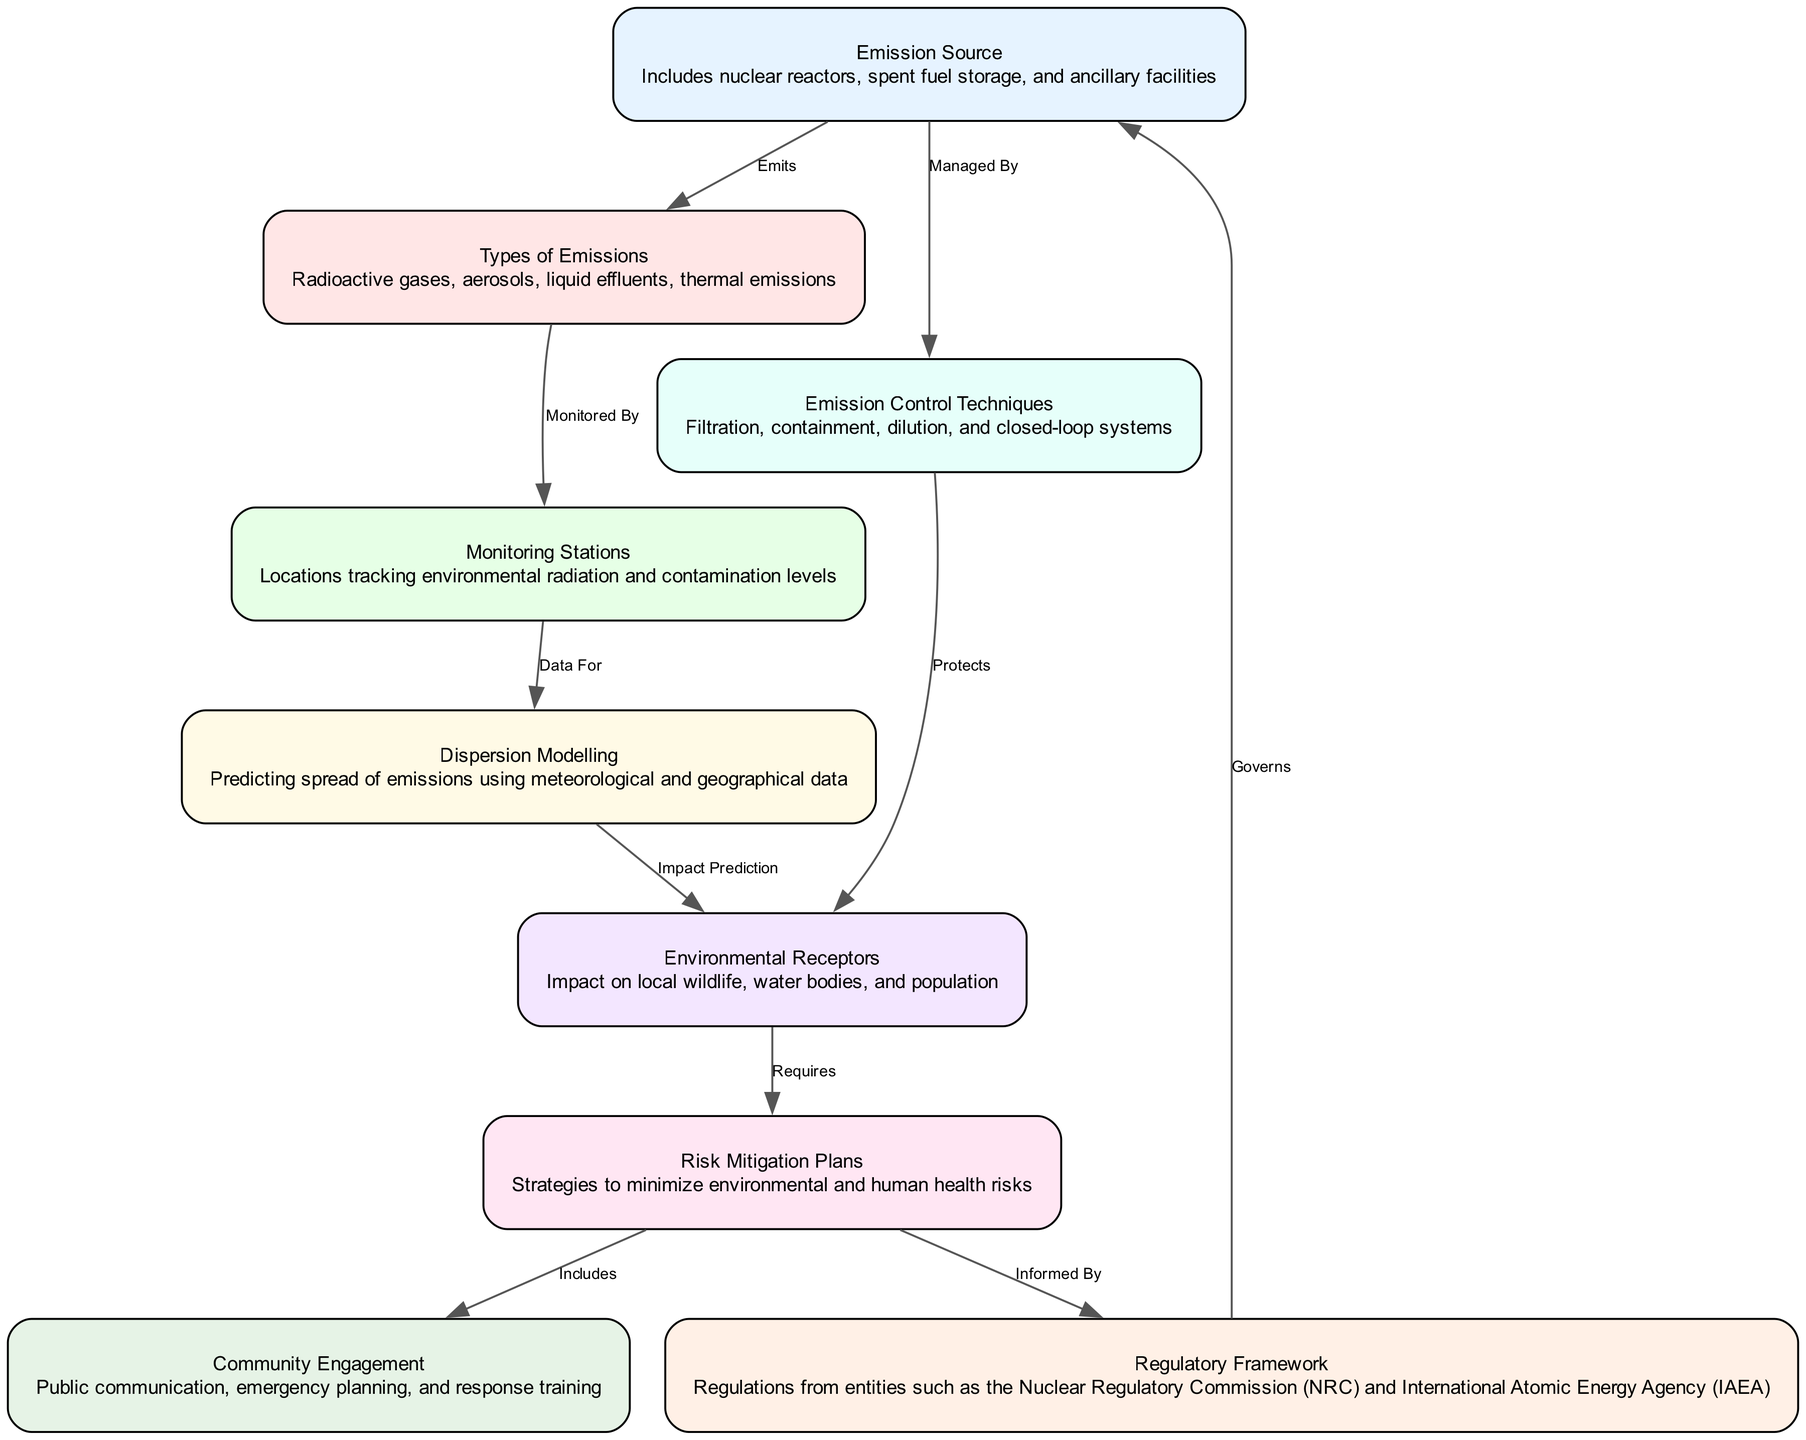What's the total number of nodes in the diagram? There are 9 nodes listed in the diagram, including emission sources, emission types, monitoring stations, dispersion modeling, environmental receptors, risk mitigation plans, emission control techniques, regulatory framework, and community engagement.
Answer: 9 What type of emissions are emitted from emission sources? The emission source node indicates that emissions include radioactive gases, aerosols, liquid effluents, and thermal emissions. These types connect directly to the emission source.
Answer: Radioactive gases, aerosols, liquid effluents, thermal emissions Which node provides data for dispersion modeling? The edge labeled "Data For" leads from the monitoring stations node to the dispersion modeling node, indicating that monitoring stations provide necessary data for dispersion modeling.
Answer: Monitoring Stations How do emission control techniques protect environmental receptors? The edge labeled "Protects" connects emission control techniques to environmental receptors, suggesting that these techniques are designed to minimize the impact on environmental receptors like local wildlife and water bodies.
Answer: Protects What are the components of risk mitigation plans informed by? The edge labeled "Informed By" shows that risk mitigation plans are informed by the regulatory framework, which includes regulations from entities such as the NRC and IAEA.
Answer: Regulatory Framework What requires risk mitigation plans in the diagram? The edge labeled "Requires" indicates the connection from environmental receptors to risk mitigation plans, implying that assessing the impact on environmental receptors necessitates the development of risk mitigation plans.
Answer: Environmental Receptors How is community engagement included in risk mitigation plans? The edge labeled "Includes" extends from risk mitigation plans to community engagement, meaning community engagement efforts are part of the strategies for risk mitigation.
Answer: Community Engagement Which organization governs emission sources? The regulatory framework node indicates that it governs the emission source, illustrating the oversight in place to regulate how emissions are managed from nuclear facilities.
Answer: Regulatory Framework What is the main purpose of monitoring stations? The monitoring stations node is described as locations tracking environmental radiation and contamination levels; hence, their main purpose is to monitor and assess environmental safety related to emissions.
Answer: Environmental radiation and contamination levels 